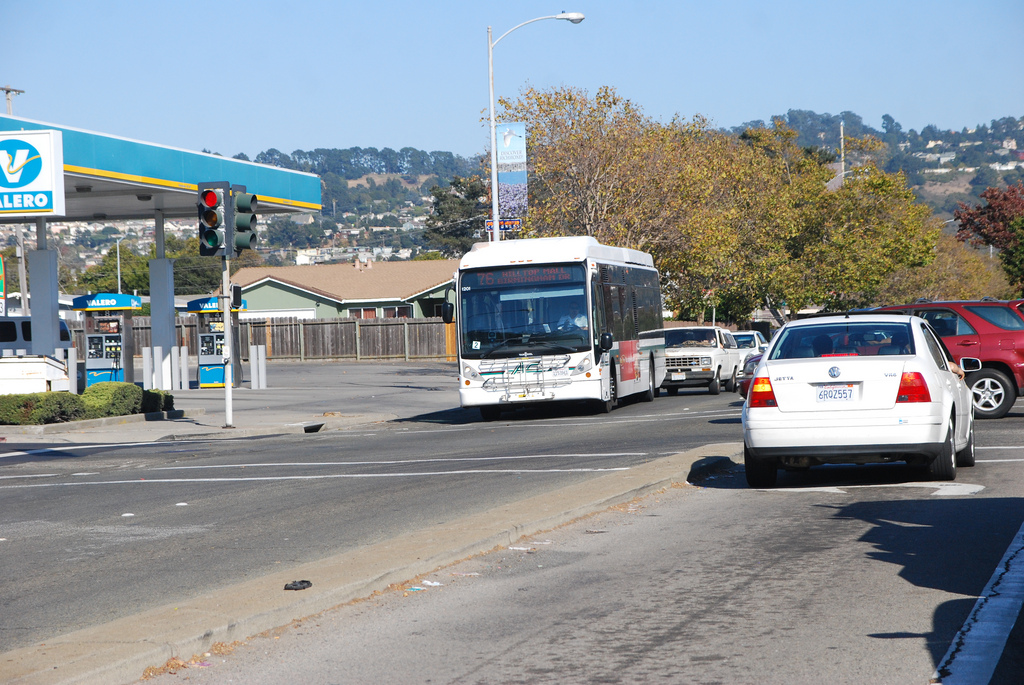Is the person to the left of the vehicle on the road? Yes, a pedestrian is visible walking on the sidewalk to the left of the white car on the road. 